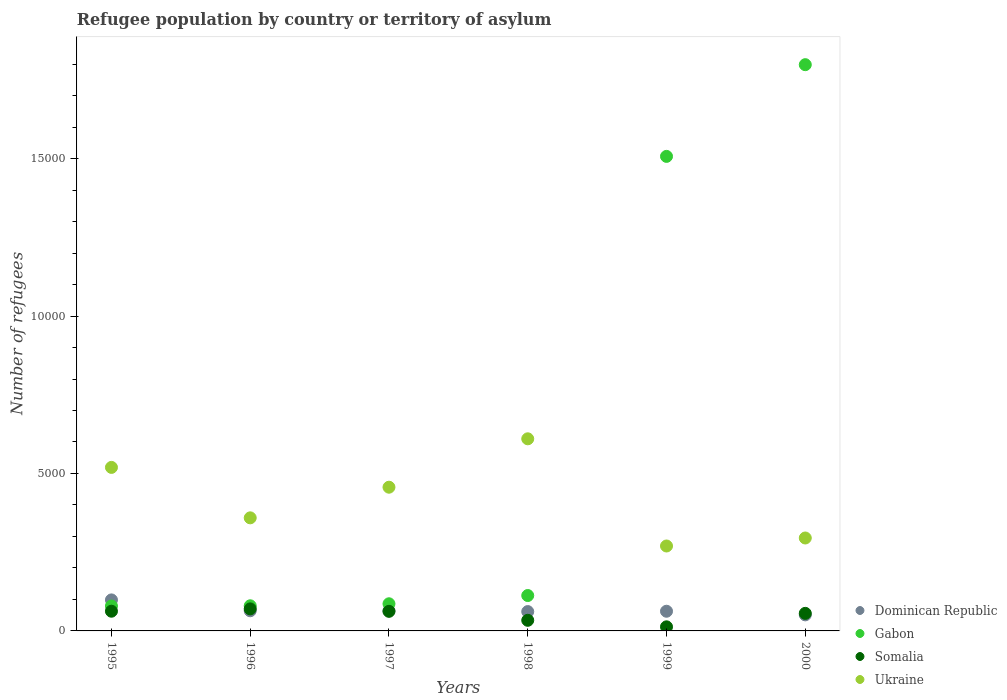What is the number of refugees in Dominican Republic in 1995?
Offer a terse response. 985. Across all years, what is the maximum number of refugees in Somalia?
Provide a succinct answer. 700. Across all years, what is the minimum number of refugees in Dominican Republic?
Give a very brief answer. 510. In which year was the number of refugees in Dominican Republic maximum?
Offer a very short reply. 1995. In which year was the number of refugees in Dominican Republic minimum?
Ensure brevity in your answer.  2000. What is the total number of refugees in Gabon in the graph?
Provide a succinct answer. 3.66e+04. What is the difference between the number of refugees in Ukraine in 1997 and that in 2000?
Your response must be concise. 1613. What is the difference between the number of refugees in Somalia in 1995 and the number of refugees in Dominican Republic in 1999?
Offer a very short reply. 1. What is the average number of refugees in Ukraine per year?
Provide a short and direct response. 4182.83. In the year 1998, what is the difference between the number of refugees in Dominican Republic and number of refugees in Gabon?
Your answer should be very brief. -510. What is the ratio of the number of refugees in Somalia in 1998 to that in 1999?
Make the answer very short. 2.59. Is the number of refugees in Ukraine in 1995 less than that in 1996?
Keep it short and to the point. No. Is the difference between the number of refugees in Dominican Republic in 1995 and 1997 greater than the difference between the number of refugees in Gabon in 1995 and 1997?
Your response must be concise. Yes. What is the difference between the highest and the second highest number of refugees in Ukraine?
Provide a succinct answer. 908. What is the difference between the highest and the lowest number of refugees in Dominican Republic?
Make the answer very short. 475. In how many years, is the number of refugees in Dominican Republic greater than the average number of refugees in Dominican Republic taken over all years?
Your answer should be compact. 1. Is it the case that in every year, the sum of the number of refugees in Ukraine and number of refugees in Gabon  is greater than the sum of number of refugees in Dominican Republic and number of refugees in Somalia?
Offer a very short reply. Yes. Does the number of refugees in Gabon monotonically increase over the years?
Provide a succinct answer. Yes. Is the number of refugees in Dominican Republic strictly greater than the number of refugees in Somalia over the years?
Keep it short and to the point. No. Is the number of refugees in Ukraine strictly less than the number of refugees in Somalia over the years?
Your response must be concise. No. How many dotlines are there?
Your answer should be compact. 4. How many years are there in the graph?
Your answer should be very brief. 6. What is the difference between two consecutive major ticks on the Y-axis?
Your answer should be compact. 5000. Are the values on the major ticks of Y-axis written in scientific E-notation?
Offer a terse response. No. Does the graph contain any zero values?
Offer a terse response. No. Does the graph contain grids?
Offer a terse response. No. How many legend labels are there?
Your response must be concise. 4. How are the legend labels stacked?
Your answer should be compact. Vertical. What is the title of the graph?
Provide a short and direct response. Refugee population by country or territory of asylum. Does "Vietnam" appear as one of the legend labels in the graph?
Offer a very short reply. No. What is the label or title of the X-axis?
Make the answer very short. Years. What is the label or title of the Y-axis?
Make the answer very short. Number of refugees. What is the Number of refugees of Dominican Republic in 1995?
Your response must be concise. 985. What is the Number of refugees in Gabon in 1995?
Your response must be concise. 791. What is the Number of refugees of Somalia in 1995?
Offer a very short reply. 626. What is the Number of refugees of Ukraine in 1995?
Make the answer very short. 5193. What is the Number of refugees of Dominican Republic in 1996?
Your response must be concise. 640. What is the Number of refugees in Gabon in 1996?
Provide a short and direct response. 798. What is the Number of refugees of Somalia in 1996?
Offer a very short reply. 700. What is the Number of refugees in Ukraine in 1996?
Your response must be concise. 3591. What is the Number of refugees in Dominican Republic in 1997?
Ensure brevity in your answer.  638. What is the Number of refugees of Gabon in 1997?
Provide a short and direct response. 862. What is the Number of refugees of Somalia in 1997?
Offer a terse response. 622. What is the Number of refugees in Ukraine in 1997?
Ensure brevity in your answer.  4564. What is the Number of refugees in Dominican Republic in 1998?
Your response must be concise. 614. What is the Number of refugees of Gabon in 1998?
Your answer should be very brief. 1124. What is the Number of refugees in Somalia in 1998?
Offer a terse response. 337. What is the Number of refugees of Ukraine in 1998?
Keep it short and to the point. 6101. What is the Number of refugees in Dominican Republic in 1999?
Your response must be concise. 625. What is the Number of refugees of Gabon in 1999?
Provide a succinct answer. 1.51e+04. What is the Number of refugees of Somalia in 1999?
Your response must be concise. 130. What is the Number of refugees of Ukraine in 1999?
Your answer should be compact. 2697. What is the Number of refugees of Dominican Republic in 2000?
Your answer should be compact. 510. What is the Number of refugees in Gabon in 2000?
Keep it short and to the point. 1.80e+04. What is the Number of refugees of Somalia in 2000?
Keep it short and to the point. 558. What is the Number of refugees of Ukraine in 2000?
Ensure brevity in your answer.  2951. Across all years, what is the maximum Number of refugees in Dominican Republic?
Ensure brevity in your answer.  985. Across all years, what is the maximum Number of refugees in Gabon?
Provide a succinct answer. 1.80e+04. Across all years, what is the maximum Number of refugees in Somalia?
Keep it short and to the point. 700. Across all years, what is the maximum Number of refugees of Ukraine?
Ensure brevity in your answer.  6101. Across all years, what is the minimum Number of refugees in Dominican Republic?
Give a very brief answer. 510. Across all years, what is the minimum Number of refugees in Gabon?
Your answer should be very brief. 791. Across all years, what is the minimum Number of refugees in Somalia?
Provide a short and direct response. 130. Across all years, what is the minimum Number of refugees in Ukraine?
Offer a very short reply. 2697. What is the total Number of refugees of Dominican Republic in the graph?
Your answer should be compact. 4012. What is the total Number of refugees of Gabon in the graph?
Your response must be concise. 3.66e+04. What is the total Number of refugees of Somalia in the graph?
Provide a short and direct response. 2973. What is the total Number of refugees of Ukraine in the graph?
Give a very brief answer. 2.51e+04. What is the difference between the Number of refugees of Dominican Republic in 1995 and that in 1996?
Your answer should be compact. 345. What is the difference between the Number of refugees in Somalia in 1995 and that in 1996?
Make the answer very short. -74. What is the difference between the Number of refugees of Ukraine in 1995 and that in 1996?
Give a very brief answer. 1602. What is the difference between the Number of refugees in Dominican Republic in 1995 and that in 1997?
Your answer should be very brief. 347. What is the difference between the Number of refugees in Gabon in 1995 and that in 1997?
Your answer should be compact. -71. What is the difference between the Number of refugees in Ukraine in 1995 and that in 1997?
Give a very brief answer. 629. What is the difference between the Number of refugees in Dominican Republic in 1995 and that in 1998?
Provide a short and direct response. 371. What is the difference between the Number of refugees of Gabon in 1995 and that in 1998?
Your response must be concise. -333. What is the difference between the Number of refugees of Somalia in 1995 and that in 1998?
Provide a succinct answer. 289. What is the difference between the Number of refugees of Ukraine in 1995 and that in 1998?
Make the answer very short. -908. What is the difference between the Number of refugees in Dominican Republic in 1995 and that in 1999?
Offer a very short reply. 360. What is the difference between the Number of refugees in Gabon in 1995 and that in 1999?
Provide a succinct answer. -1.43e+04. What is the difference between the Number of refugees of Somalia in 1995 and that in 1999?
Give a very brief answer. 496. What is the difference between the Number of refugees of Ukraine in 1995 and that in 1999?
Make the answer very short. 2496. What is the difference between the Number of refugees of Dominican Republic in 1995 and that in 2000?
Provide a succinct answer. 475. What is the difference between the Number of refugees of Gabon in 1995 and that in 2000?
Make the answer very short. -1.72e+04. What is the difference between the Number of refugees of Somalia in 1995 and that in 2000?
Your response must be concise. 68. What is the difference between the Number of refugees in Ukraine in 1995 and that in 2000?
Offer a terse response. 2242. What is the difference between the Number of refugees in Dominican Republic in 1996 and that in 1997?
Your answer should be compact. 2. What is the difference between the Number of refugees of Gabon in 1996 and that in 1997?
Provide a short and direct response. -64. What is the difference between the Number of refugees of Somalia in 1996 and that in 1997?
Your answer should be very brief. 78. What is the difference between the Number of refugees of Ukraine in 1996 and that in 1997?
Offer a very short reply. -973. What is the difference between the Number of refugees of Gabon in 1996 and that in 1998?
Your answer should be compact. -326. What is the difference between the Number of refugees of Somalia in 1996 and that in 1998?
Ensure brevity in your answer.  363. What is the difference between the Number of refugees of Ukraine in 1996 and that in 1998?
Provide a succinct answer. -2510. What is the difference between the Number of refugees in Dominican Republic in 1996 and that in 1999?
Your response must be concise. 15. What is the difference between the Number of refugees of Gabon in 1996 and that in 1999?
Your answer should be very brief. -1.43e+04. What is the difference between the Number of refugees in Somalia in 1996 and that in 1999?
Ensure brevity in your answer.  570. What is the difference between the Number of refugees of Ukraine in 1996 and that in 1999?
Your answer should be compact. 894. What is the difference between the Number of refugees in Dominican Republic in 1996 and that in 2000?
Offer a very short reply. 130. What is the difference between the Number of refugees in Gabon in 1996 and that in 2000?
Your answer should be compact. -1.72e+04. What is the difference between the Number of refugees of Somalia in 1996 and that in 2000?
Your response must be concise. 142. What is the difference between the Number of refugees of Ukraine in 1996 and that in 2000?
Keep it short and to the point. 640. What is the difference between the Number of refugees of Dominican Republic in 1997 and that in 1998?
Offer a terse response. 24. What is the difference between the Number of refugees in Gabon in 1997 and that in 1998?
Give a very brief answer. -262. What is the difference between the Number of refugees of Somalia in 1997 and that in 1998?
Offer a very short reply. 285. What is the difference between the Number of refugees of Ukraine in 1997 and that in 1998?
Offer a very short reply. -1537. What is the difference between the Number of refugees in Dominican Republic in 1997 and that in 1999?
Offer a very short reply. 13. What is the difference between the Number of refugees in Gabon in 1997 and that in 1999?
Keep it short and to the point. -1.42e+04. What is the difference between the Number of refugees in Somalia in 1997 and that in 1999?
Give a very brief answer. 492. What is the difference between the Number of refugees of Ukraine in 1997 and that in 1999?
Provide a short and direct response. 1867. What is the difference between the Number of refugees of Dominican Republic in 1997 and that in 2000?
Keep it short and to the point. 128. What is the difference between the Number of refugees in Gabon in 1997 and that in 2000?
Give a very brief answer. -1.71e+04. What is the difference between the Number of refugees in Somalia in 1997 and that in 2000?
Offer a terse response. 64. What is the difference between the Number of refugees in Ukraine in 1997 and that in 2000?
Provide a short and direct response. 1613. What is the difference between the Number of refugees in Gabon in 1998 and that in 1999?
Make the answer very short. -1.39e+04. What is the difference between the Number of refugees in Somalia in 1998 and that in 1999?
Offer a very short reply. 207. What is the difference between the Number of refugees in Ukraine in 1998 and that in 1999?
Provide a succinct answer. 3404. What is the difference between the Number of refugees in Dominican Republic in 1998 and that in 2000?
Offer a very short reply. 104. What is the difference between the Number of refugees in Gabon in 1998 and that in 2000?
Offer a terse response. -1.69e+04. What is the difference between the Number of refugees in Somalia in 1998 and that in 2000?
Ensure brevity in your answer.  -221. What is the difference between the Number of refugees of Ukraine in 1998 and that in 2000?
Offer a terse response. 3150. What is the difference between the Number of refugees of Dominican Republic in 1999 and that in 2000?
Ensure brevity in your answer.  115. What is the difference between the Number of refugees of Gabon in 1999 and that in 2000?
Your answer should be compact. -2912. What is the difference between the Number of refugees of Somalia in 1999 and that in 2000?
Provide a succinct answer. -428. What is the difference between the Number of refugees in Ukraine in 1999 and that in 2000?
Make the answer very short. -254. What is the difference between the Number of refugees of Dominican Republic in 1995 and the Number of refugees of Gabon in 1996?
Keep it short and to the point. 187. What is the difference between the Number of refugees in Dominican Republic in 1995 and the Number of refugees in Somalia in 1996?
Offer a very short reply. 285. What is the difference between the Number of refugees in Dominican Republic in 1995 and the Number of refugees in Ukraine in 1996?
Offer a terse response. -2606. What is the difference between the Number of refugees of Gabon in 1995 and the Number of refugees of Somalia in 1996?
Offer a terse response. 91. What is the difference between the Number of refugees in Gabon in 1995 and the Number of refugees in Ukraine in 1996?
Ensure brevity in your answer.  -2800. What is the difference between the Number of refugees of Somalia in 1995 and the Number of refugees of Ukraine in 1996?
Your answer should be compact. -2965. What is the difference between the Number of refugees in Dominican Republic in 1995 and the Number of refugees in Gabon in 1997?
Your answer should be compact. 123. What is the difference between the Number of refugees of Dominican Republic in 1995 and the Number of refugees of Somalia in 1997?
Provide a short and direct response. 363. What is the difference between the Number of refugees in Dominican Republic in 1995 and the Number of refugees in Ukraine in 1997?
Your response must be concise. -3579. What is the difference between the Number of refugees of Gabon in 1995 and the Number of refugees of Somalia in 1997?
Keep it short and to the point. 169. What is the difference between the Number of refugees of Gabon in 1995 and the Number of refugees of Ukraine in 1997?
Your response must be concise. -3773. What is the difference between the Number of refugees of Somalia in 1995 and the Number of refugees of Ukraine in 1997?
Ensure brevity in your answer.  -3938. What is the difference between the Number of refugees of Dominican Republic in 1995 and the Number of refugees of Gabon in 1998?
Offer a terse response. -139. What is the difference between the Number of refugees of Dominican Republic in 1995 and the Number of refugees of Somalia in 1998?
Your response must be concise. 648. What is the difference between the Number of refugees of Dominican Republic in 1995 and the Number of refugees of Ukraine in 1998?
Offer a very short reply. -5116. What is the difference between the Number of refugees in Gabon in 1995 and the Number of refugees in Somalia in 1998?
Give a very brief answer. 454. What is the difference between the Number of refugees of Gabon in 1995 and the Number of refugees of Ukraine in 1998?
Offer a very short reply. -5310. What is the difference between the Number of refugees in Somalia in 1995 and the Number of refugees in Ukraine in 1998?
Provide a short and direct response. -5475. What is the difference between the Number of refugees in Dominican Republic in 1995 and the Number of refugees in Gabon in 1999?
Your answer should be very brief. -1.41e+04. What is the difference between the Number of refugees of Dominican Republic in 1995 and the Number of refugees of Somalia in 1999?
Your answer should be compact. 855. What is the difference between the Number of refugees in Dominican Republic in 1995 and the Number of refugees in Ukraine in 1999?
Provide a succinct answer. -1712. What is the difference between the Number of refugees in Gabon in 1995 and the Number of refugees in Somalia in 1999?
Your response must be concise. 661. What is the difference between the Number of refugees of Gabon in 1995 and the Number of refugees of Ukraine in 1999?
Your answer should be very brief. -1906. What is the difference between the Number of refugees in Somalia in 1995 and the Number of refugees in Ukraine in 1999?
Offer a very short reply. -2071. What is the difference between the Number of refugees in Dominican Republic in 1995 and the Number of refugees in Gabon in 2000?
Your answer should be compact. -1.70e+04. What is the difference between the Number of refugees of Dominican Republic in 1995 and the Number of refugees of Somalia in 2000?
Your response must be concise. 427. What is the difference between the Number of refugees in Dominican Republic in 1995 and the Number of refugees in Ukraine in 2000?
Make the answer very short. -1966. What is the difference between the Number of refugees of Gabon in 1995 and the Number of refugees of Somalia in 2000?
Your answer should be very brief. 233. What is the difference between the Number of refugees in Gabon in 1995 and the Number of refugees in Ukraine in 2000?
Offer a very short reply. -2160. What is the difference between the Number of refugees in Somalia in 1995 and the Number of refugees in Ukraine in 2000?
Keep it short and to the point. -2325. What is the difference between the Number of refugees of Dominican Republic in 1996 and the Number of refugees of Gabon in 1997?
Keep it short and to the point. -222. What is the difference between the Number of refugees of Dominican Republic in 1996 and the Number of refugees of Somalia in 1997?
Keep it short and to the point. 18. What is the difference between the Number of refugees of Dominican Republic in 1996 and the Number of refugees of Ukraine in 1997?
Keep it short and to the point. -3924. What is the difference between the Number of refugees in Gabon in 1996 and the Number of refugees in Somalia in 1997?
Your answer should be very brief. 176. What is the difference between the Number of refugees of Gabon in 1996 and the Number of refugees of Ukraine in 1997?
Your answer should be very brief. -3766. What is the difference between the Number of refugees in Somalia in 1996 and the Number of refugees in Ukraine in 1997?
Your answer should be compact. -3864. What is the difference between the Number of refugees in Dominican Republic in 1996 and the Number of refugees in Gabon in 1998?
Ensure brevity in your answer.  -484. What is the difference between the Number of refugees in Dominican Republic in 1996 and the Number of refugees in Somalia in 1998?
Ensure brevity in your answer.  303. What is the difference between the Number of refugees of Dominican Republic in 1996 and the Number of refugees of Ukraine in 1998?
Keep it short and to the point. -5461. What is the difference between the Number of refugees in Gabon in 1996 and the Number of refugees in Somalia in 1998?
Keep it short and to the point. 461. What is the difference between the Number of refugees of Gabon in 1996 and the Number of refugees of Ukraine in 1998?
Keep it short and to the point. -5303. What is the difference between the Number of refugees of Somalia in 1996 and the Number of refugees of Ukraine in 1998?
Ensure brevity in your answer.  -5401. What is the difference between the Number of refugees of Dominican Republic in 1996 and the Number of refugees of Gabon in 1999?
Ensure brevity in your answer.  -1.44e+04. What is the difference between the Number of refugees of Dominican Republic in 1996 and the Number of refugees of Somalia in 1999?
Offer a terse response. 510. What is the difference between the Number of refugees of Dominican Republic in 1996 and the Number of refugees of Ukraine in 1999?
Offer a very short reply. -2057. What is the difference between the Number of refugees of Gabon in 1996 and the Number of refugees of Somalia in 1999?
Your answer should be compact. 668. What is the difference between the Number of refugees in Gabon in 1996 and the Number of refugees in Ukraine in 1999?
Give a very brief answer. -1899. What is the difference between the Number of refugees of Somalia in 1996 and the Number of refugees of Ukraine in 1999?
Ensure brevity in your answer.  -1997. What is the difference between the Number of refugees in Dominican Republic in 1996 and the Number of refugees in Gabon in 2000?
Your answer should be compact. -1.73e+04. What is the difference between the Number of refugees of Dominican Republic in 1996 and the Number of refugees of Somalia in 2000?
Offer a terse response. 82. What is the difference between the Number of refugees of Dominican Republic in 1996 and the Number of refugees of Ukraine in 2000?
Your answer should be compact. -2311. What is the difference between the Number of refugees in Gabon in 1996 and the Number of refugees in Somalia in 2000?
Provide a succinct answer. 240. What is the difference between the Number of refugees in Gabon in 1996 and the Number of refugees in Ukraine in 2000?
Your answer should be compact. -2153. What is the difference between the Number of refugees of Somalia in 1996 and the Number of refugees of Ukraine in 2000?
Your answer should be compact. -2251. What is the difference between the Number of refugees in Dominican Republic in 1997 and the Number of refugees in Gabon in 1998?
Give a very brief answer. -486. What is the difference between the Number of refugees in Dominican Republic in 1997 and the Number of refugees in Somalia in 1998?
Offer a very short reply. 301. What is the difference between the Number of refugees in Dominican Republic in 1997 and the Number of refugees in Ukraine in 1998?
Ensure brevity in your answer.  -5463. What is the difference between the Number of refugees of Gabon in 1997 and the Number of refugees of Somalia in 1998?
Make the answer very short. 525. What is the difference between the Number of refugees of Gabon in 1997 and the Number of refugees of Ukraine in 1998?
Your response must be concise. -5239. What is the difference between the Number of refugees in Somalia in 1997 and the Number of refugees in Ukraine in 1998?
Offer a very short reply. -5479. What is the difference between the Number of refugees in Dominican Republic in 1997 and the Number of refugees in Gabon in 1999?
Ensure brevity in your answer.  -1.44e+04. What is the difference between the Number of refugees in Dominican Republic in 1997 and the Number of refugees in Somalia in 1999?
Your answer should be compact. 508. What is the difference between the Number of refugees of Dominican Republic in 1997 and the Number of refugees of Ukraine in 1999?
Ensure brevity in your answer.  -2059. What is the difference between the Number of refugees of Gabon in 1997 and the Number of refugees of Somalia in 1999?
Your response must be concise. 732. What is the difference between the Number of refugees of Gabon in 1997 and the Number of refugees of Ukraine in 1999?
Your answer should be very brief. -1835. What is the difference between the Number of refugees of Somalia in 1997 and the Number of refugees of Ukraine in 1999?
Keep it short and to the point. -2075. What is the difference between the Number of refugees of Dominican Republic in 1997 and the Number of refugees of Gabon in 2000?
Offer a very short reply. -1.73e+04. What is the difference between the Number of refugees in Dominican Republic in 1997 and the Number of refugees in Ukraine in 2000?
Keep it short and to the point. -2313. What is the difference between the Number of refugees of Gabon in 1997 and the Number of refugees of Somalia in 2000?
Your answer should be compact. 304. What is the difference between the Number of refugees in Gabon in 1997 and the Number of refugees in Ukraine in 2000?
Ensure brevity in your answer.  -2089. What is the difference between the Number of refugees of Somalia in 1997 and the Number of refugees of Ukraine in 2000?
Provide a short and direct response. -2329. What is the difference between the Number of refugees of Dominican Republic in 1998 and the Number of refugees of Gabon in 1999?
Ensure brevity in your answer.  -1.45e+04. What is the difference between the Number of refugees in Dominican Republic in 1998 and the Number of refugees in Somalia in 1999?
Offer a terse response. 484. What is the difference between the Number of refugees of Dominican Republic in 1998 and the Number of refugees of Ukraine in 1999?
Provide a succinct answer. -2083. What is the difference between the Number of refugees in Gabon in 1998 and the Number of refugees in Somalia in 1999?
Make the answer very short. 994. What is the difference between the Number of refugees in Gabon in 1998 and the Number of refugees in Ukraine in 1999?
Provide a short and direct response. -1573. What is the difference between the Number of refugees of Somalia in 1998 and the Number of refugees of Ukraine in 1999?
Give a very brief answer. -2360. What is the difference between the Number of refugees in Dominican Republic in 1998 and the Number of refugees in Gabon in 2000?
Your response must be concise. -1.74e+04. What is the difference between the Number of refugees in Dominican Republic in 1998 and the Number of refugees in Ukraine in 2000?
Keep it short and to the point. -2337. What is the difference between the Number of refugees of Gabon in 1998 and the Number of refugees of Somalia in 2000?
Your answer should be very brief. 566. What is the difference between the Number of refugees of Gabon in 1998 and the Number of refugees of Ukraine in 2000?
Give a very brief answer. -1827. What is the difference between the Number of refugees of Somalia in 1998 and the Number of refugees of Ukraine in 2000?
Make the answer very short. -2614. What is the difference between the Number of refugees of Dominican Republic in 1999 and the Number of refugees of Gabon in 2000?
Give a very brief answer. -1.74e+04. What is the difference between the Number of refugees in Dominican Republic in 1999 and the Number of refugees in Ukraine in 2000?
Ensure brevity in your answer.  -2326. What is the difference between the Number of refugees of Gabon in 1999 and the Number of refugees of Somalia in 2000?
Keep it short and to the point. 1.45e+04. What is the difference between the Number of refugees of Gabon in 1999 and the Number of refugees of Ukraine in 2000?
Ensure brevity in your answer.  1.21e+04. What is the difference between the Number of refugees of Somalia in 1999 and the Number of refugees of Ukraine in 2000?
Give a very brief answer. -2821. What is the average Number of refugees of Dominican Republic per year?
Your answer should be compact. 668.67. What is the average Number of refugees of Gabon per year?
Provide a succinct answer. 6104.5. What is the average Number of refugees in Somalia per year?
Make the answer very short. 495.5. What is the average Number of refugees of Ukraine per year?
Your response must be concise. 4182.83. In the year 1995, what is the difference between the Number of refugees of Dominican Republic and Number of refugees of Gabon?
Offer a terse response. 194. In the year 1995, what is the difference between the Number of refugees of Dominican Republic and Number of refugees of Somalia?
Your response must be concise. 359. In the year 1995, what is the difference between the Number of refugees of Dominican Republic and Number of refugees of Ukraine?
Offer a very short reply. -4208. In the year 1995, what is the difference between the Number of refugees in Gabon and Number of refugees in Somalia?
Your answer should be very brief. 165. In the year 1995, what is the difference between the Number of refugees in Gabon and Number of refugees in Ukraine?
Provide a succinct answer. -4402. In the year 1995, what is the difference between the Number of refugees in Somalia and Number of refugees in Ukraine?
Provide a succinct answer. -4567. In the year 1996, what is the difference between the Number of refugees in Dominican Republic and Number of refugees in Gabon?
Offer a very short reply. -158. In the year 1996, what is the difference between the Number of refugees in Dominican Republic and Number of refugees in Somalia?
Make the answer very short. -60. In the year 1996, what is the difference between the Number of refugees of Dominican Republic and Number of refugees of Ukraine?
Provide a short and direct response. -2951. In the year 1996, what is the difference between the Number of refugees in Gabon and Number of refugees in Ukraine?
Ensure brevity in your answer.  -2793. In the year 1996, what is the difference between the Number of refugees in Somalia and Number of refugees in Ukraine?
Make the answer very short. -2891. In the year 1997, what is the difference between the Number of refugees in Dominican Republic and Number of refugees in Gabon?
Ensure brevity in your answer.  -224. In the year 1997, what is the difference between the Number of refugees of Dominican Republic and Number of refugees of Somalia?
Give a very brief answer. 16. In the year 1997, what is the difference between the Number of refugees of Dominican Republic and Number of refugees of Ukraine?
Your answer should be very brief. -3926. In the year 1997, what is the difference between the Number of refugees in Gabon and Number of refugees in Somalia?
Give a very brief answer. 240. In the year 1997, what is the difference between the Number of refugees of Gabon and Number of refugees of Ukraine?
Your answer should be very brief. -3702. In the year 1997, what is the difference between the Number of refugees of Somalia and Number of refugees of Ukraine?
Provide a short and direct response. -3942. In the year 1998, what is the difference between the Number of refugees in Dominican Republic and Number of refugees in Gabon?
Provide a succinct answer. -510. In the year 1998, what is the difference between the Number of refugees in Dominican Republic and Number of refugees in Somalia?
Your answer should be very brief. 277. In the year 1998, what is the difference between the Number of refugees of Dominican Republic and Number of refugees of Ukraine?
Keep it short and to the point. -5487. In the year 1998, what is the difference between the Number of refugees of Gabon and Number of refugees of Somalia?
Provide a short and direct response. 787. In the year 1998, what is the difference between the Number of refugees of Gabon and Number of refugees of Ukraine?
Provide a succinct answer. -4977. In the year 1998, what is the difference between the Number of refugees in Somalia and Number of refugees in Ukraine?
Keep it short and to the point. -5764. In the year 1999, what is the difference between the Number of refugees of Dominican Republic and Number of refugees of Gabon?
Your response must be concise. -1.44e+04. In the year 1999, what is the difference between the Number of refugees of Dominican Republic and Number of refugees of Somalia?
Provide a short and direct response. 495. In the year 1999, what is the difference between the Number of refugees of Dominican Republic and Number of refugees of Ukraine?
Give a very brief answer. -2072. In the year 1999, what is the difference between the Number of refugees in Gabon and Number of refugees in Somalia?
Provide a succinct answer. 1.49e+04. In the year 1999, what is the difference between the Number of refugees in Gabon and Number of refugees in Ukraine?
Provide a succinct answer. 1.24e+04. In the year 1999, what is the difference between the Number of refugees in Somalia and Number of refugees in Ukraine?
Your answer should be compact. -2567. In the year 2000, what is the difference between the Number of refugees of Dominican Republic and Number of refugees of Gabon?
Make the answer very short. -1.75e+04. In the year 2000, what is the difference between the Number of refugees of Dominican Republic and Number of refugees of Somalia?
Keep it short and to the point. -48. In the year 2000, what is the difference between the Number of refugees in Dominican Republic and Number of refugees in Ukraine?
Ensure brevity in your answer.  -2441. In the year 2000, what is the difference between the Number of refugees of Gabon and Number of refugees of Somalia?
Your answer should be very brief. 1.74e+04. In the year 2000, what is the difference between the Number of refugees of Gabon and Number of refugees of Ukraine?
Provide a succinct answer. 1.50e+04. In the year 2000, what is the difference between the Number of refugees of Somalia and Number of refugees of Ukraine?
Give a very brief answer. -2393. What is the ratio of the Number of refugees of Dominican Republic in 1995 to that in 1996?
Offer a terse response. 1.54. What is the ratio of the Number of refugees of Gabon in 1995 to that in 1996?
Make the answer very short. 0.99. What is the ratio of the Number of refugees of Somalia in 1995 to that in 1996?
Keep it short and to the point. 0.89. What is the ratio of the Number of refugees in Ukraine in 1995 to that in 1996?
Offer a terse response. 1.45. What is the ratio of the Number of refugees of Dominican Republic in 1995 to that in 1997?
Your answer should be compact. 1.54. What is the ratio of the Number of refugees in Gabon in 1995 to that in 1997?
Offer a terse response. 0.92. What is the ratio of the Number of refugees in Somalia in 1995 to that in 1997?
Provide a succinct answer. 1.01. What is the ratio of the Number of refugees of Ukraine in 1995 to that in 1997?
Offer a very short reply. 1.14. What is the ratio of the Number of refugees of Dominican Republic in 1995 to that in 1998?
Your response must be concise. 1.6. What is the ratio of the Number of refugees in Gabon in 1995 to that in 1998?
Keep it short and to the point. 0.7. What is the ratio of the Number of refugees in Somalia in 1995 to that in 1998?
Make the answer very short. 1.86. What is the ratio of the Number of refugees in Ukraine in 1995 to that in 1998?
Offer a terse response. 0.85. What is the ratio of the Number of refugees of Dominican Republic in 1995 to that in 1999?
Keep it short and to the point. 1.58. What is the ratio of the Number of refugees of Gabon in 1995 to that in 1999?
Your answer should be very brief. 0.05. What is the ratio of the Number of refugees in Somalia in 1995 to that in 1999?
Make the answer very short. 4.82. What is the ratio of the Number of refugees of Ukraine in 1995 to that in 1999?
Provide a short and direct response. 1.93. What is the ratio of the Number of refugees in Dominican Republic in 1995 to that in 2000?
Provide a short and direct response. 1.93. What is the ratio of the Number of refugees in Gabon in 1995 to that in 2000?
Provide a succinct answer. 0.04. What is the ratio of the Number of refugees of Somalia in 1995 to that in 2000?
Ensure brevity in your answer.  1.12. What is the ratio of the Number of refugees of Ukraine in 1995 to that in 2000?
Keep it short and to the point. 1.76. What is the ratio of the Number of refugees of Dominican Republic in 1996 to that in 1997?
Ensure brevity in your answer.  1. What is the ratio of the Number of refugees in Gabon in 1996 to that in 1997?
Make the answer very short. 0.93. What is the ratio of the Number of refugees in Somalia in 1996 to that in 1997?
Offer a terse response. 1.13. What is the ratio of the Number of refugees in Ukraine in 1996 to that in 1997?
Provide a short and direct response. 0.79. What is the ratio of the Number of refugees of Dominican Republic in 1996 to that in 1998?
Provide a succinct answer. 1.04. What is the ratio of the Number of refugees of Gabon in 1996 to that in 1998?
Your answer should be very brief. 0.71. What is the ratio of the Number of refugees in Somalia in 1996 to that in 1998?
Offer a terse response. 2.08. What is the ratio of the Number of refugees of Ukraine in 1996 to that in 1998?
Give a very brief answer. 0.59. What is the ratio of the Number of refugees of Dominican Republic in 1996 to that in 1999?
Your answer should be very brief. 1.02. What is the ratio of the Number of refugees of Gabon in 1996 to that in 1999?
Provide a succinct answer. 0.05. What is the ratio of the Number of refugees in Somalia in 1996 to that in 1999?
Provide a short and direct response. 5.38. What is the ratio of the Number of refugees in Ukraine in 1996 to that in 1999?
Give a very brief answer. 1.33. What is the ratio of the Number of refugees in Dominican Republic in 1996 to that in 2000?
Make the answer very short. 1.25. What is the ratio of the Number of refugees in Gabon in 1996 to that in 2000?
Give a very brief answer. 0.04. What is the ratio of the Number of refugees of Somalia in 1996 to that in 2000?
Offer a terse response. 1.25. What is the ratio of the Number of refugees in Ukraine in 1996 to that in 2000?
Give a very brief answer. 1.22. What is the ratio of the Number of refugees of Dominican Republic in 1997 to that in 1998?
Your answer should be very brief. 1.04. What is the ratio of the Number of refugees in Gabon in 1997 to that in 1998?
Offer a very short reply. 0.77. What is the ratio of the Number of refugees of Somalia in 1997 to that in 1998?
Keep it short and to the point. 1.85. What is the ratio of the Number of refugees in Ukraine in 1997 to that in 1998?
Offer a very short reply. 0.75. What is the ratio of the Number of refugees in Dominican Republic in 1997 to that in 1999?
Provide a short and direct response. 1.02. What is the ratio of the Number of refugees of Gabon in 1997 to that in 1999?
Keep it short and to the point. 0.06. What is the ratio of the Number of refugees in Somalia in 1997 to that in 1999?
Give a very brief answer. 4.78. What is the ratio of the Number of refugees of Ukraine in 1997 to that in 1999?
Keep it short and to the point. 1.69. What is the ratio of the Number of refugees in Dominican Republic in 1997 to that in 2000?
Your answer should be compact. 1.25. What is the ratio of the Number of refugees in Gabon in 1997 to that in 2000?
Ensure brevity in your answer.  0.05. What is the ratio of the Number of refugees in Somalia in 1997 to that in 2000?
Your answer should be compact. 1.11. What is the ratio of the Number of refugees in Ukraine in 1997 to that in 2000?
Provide a succinct answer. 1.55. What is the ratio of the Number of refugees in Dominican Republic in 1998 to that in 1999?
Provide a succinct answer. 0.98. What is the ratio of the Number of refugees of Gabon in 1998 to that in 1999?
Your response must be concise. 0.07. What is the ratio of the Number of refugees of Somalia in 1998 to that in 1999?
Offer a very short reply. 2.59. What is the ratio of the Number of refugees of Ukraine in 1998 to that in 1999?
Keep it short and to the point. 2.26. What is the ratio of the Number of refugees of Dominican Republic in 1998 to that in 2000?
Your answer should be very brief. 1.2. What is the ratio of the Number of refugees of Gabon in 1998 to that in 2000?
Ensure brevity in your answer.  0.06. What is the ratio of the Number of refugees of Somalia in 1998 to that in 2000?
Provide a succinct answer. 0.6. What is the ratio of the Number of refugees of Ukraine in 1998 to that in 2000?
Make the answer very short. 2.07. What is the ratio of the Number of refugees in Dominican Republic in 1999 to that in 2000?
Provide a short and direct response. 1.23. What is the ratio of the Number of refugees of Gabon in 1999 to that in 2000?
Ensure brevity in your answer.  0.84. What is the ratio of the Number of refugees in Somalia in 1999 to that in 2000?
Provide a short and direct response. 0.23. What is the ratio of the Number of refugees in Ukraine in 1999 to that in 2000?
Ensure brevity in your answer.  0.91. What is the difference between the highest and the second highest Number of refugees of Dominican Republic?
Keep it short and to the point. 345. What is the difference between the highest and the second highest Number of refugees of Gabon?
Offer a very short reply. 2912. What is the difference between the highest and the second highest Number of refugees in Somalia?
Your response must be concise. 74. What is the difference between the highest and the second highest Number of refugees of Ukraine?
Provide a succinct answer. 908. What is the difference between the highest and the lowest Number of refugees in Dominican Republic?
Keep it short and to the point. 475. What is the difference between the highest and the lowest Number of refugees of Gabon?
Your answer should be compact. 1.72e+04. What is the difference between the highest and the lowest Number of refugees in Somalia?
Your response must be concise. 570. What is the difference between the highest and the lowest Number of refugees of Ukraine?
Provide a short and direct response. 3404. 